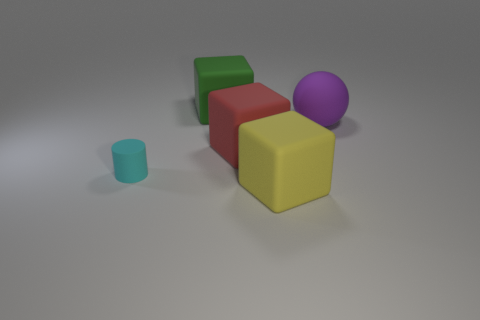Is there anything else that has the same shape as the cyan rubber thing?
Offer a very short reply. No. There is a large thing that is in front of the small matte cylinder; what is its color?
Offer a terse response. Yellow. Are there more cyan matte cylinders that are on the right side of the purple sphere than red cubes that are behind the green thing?
Your answer should be very brief. No. There is a matte block in front of the thing that is to the left of the rubber block behind the big red matte cube; what is its size?
Provide a succinct answer. Large. Is there another tiny rubber cylinder of the same color as the tiny cylinder?
Ensure brevity in your answer.  No. What number of green metallic spheres are there?
Make the answer very short. 0. The thing in front of the cyan matte cylinder on the left side of the object that is on the right side of the big yellow cube is made of what material?
Keep it short and to the point. Rubber. Is there a tiny red object made of the same material as the big green object?
Offer a terse response. No. Do the large purple object and the yellow cube have the same material?
Make the answer very short. Yes. What number of balls are either tiny brown rubber things or tiny matte things?
Make the answer very short. 0. 